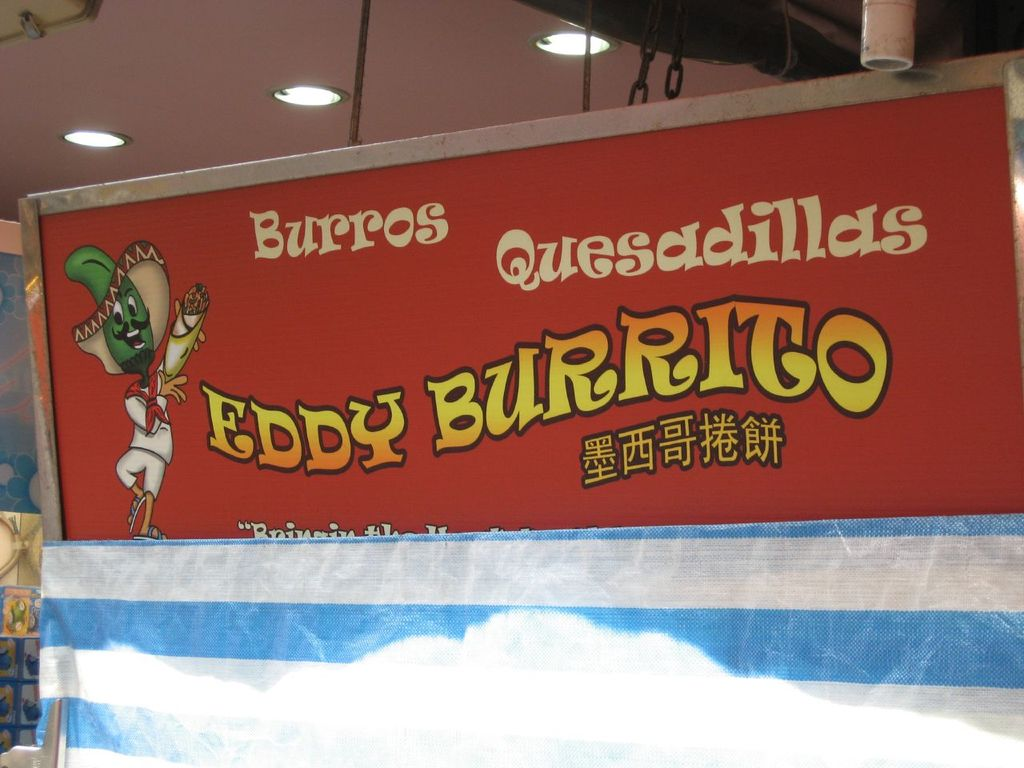How might the design and colors of the sign impact its effectiveness in attracting customers? The design and colors of the sign play a crucial role in its effectiveness. The vivid red background catches the eye quickly, making it visible from a distance, while the yellow text stands out against this backdrop, ensuring readability. The use of vibrant, contrasting colors not only grabs attention but also conveys the lively and festive spirit of Mexican culture. The cartoon-like illustration adds a fun and friendly vibe, making the restaurant appear welcoming and family-friendly. Overall, this combination of engaging visuals and clear messaging effectively attracts and entices potential customers. 